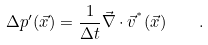<formula> <loc_0><loc_0><loc_500><loc_500>\Delta p ^ { \prime } ( \vec { x } ) = \frac { 1 } { \Delta t } \vec { \nabla } \cdot \vec { v } ^ { ^ { * } } ( \vec { x } ) \quad .</formula> 